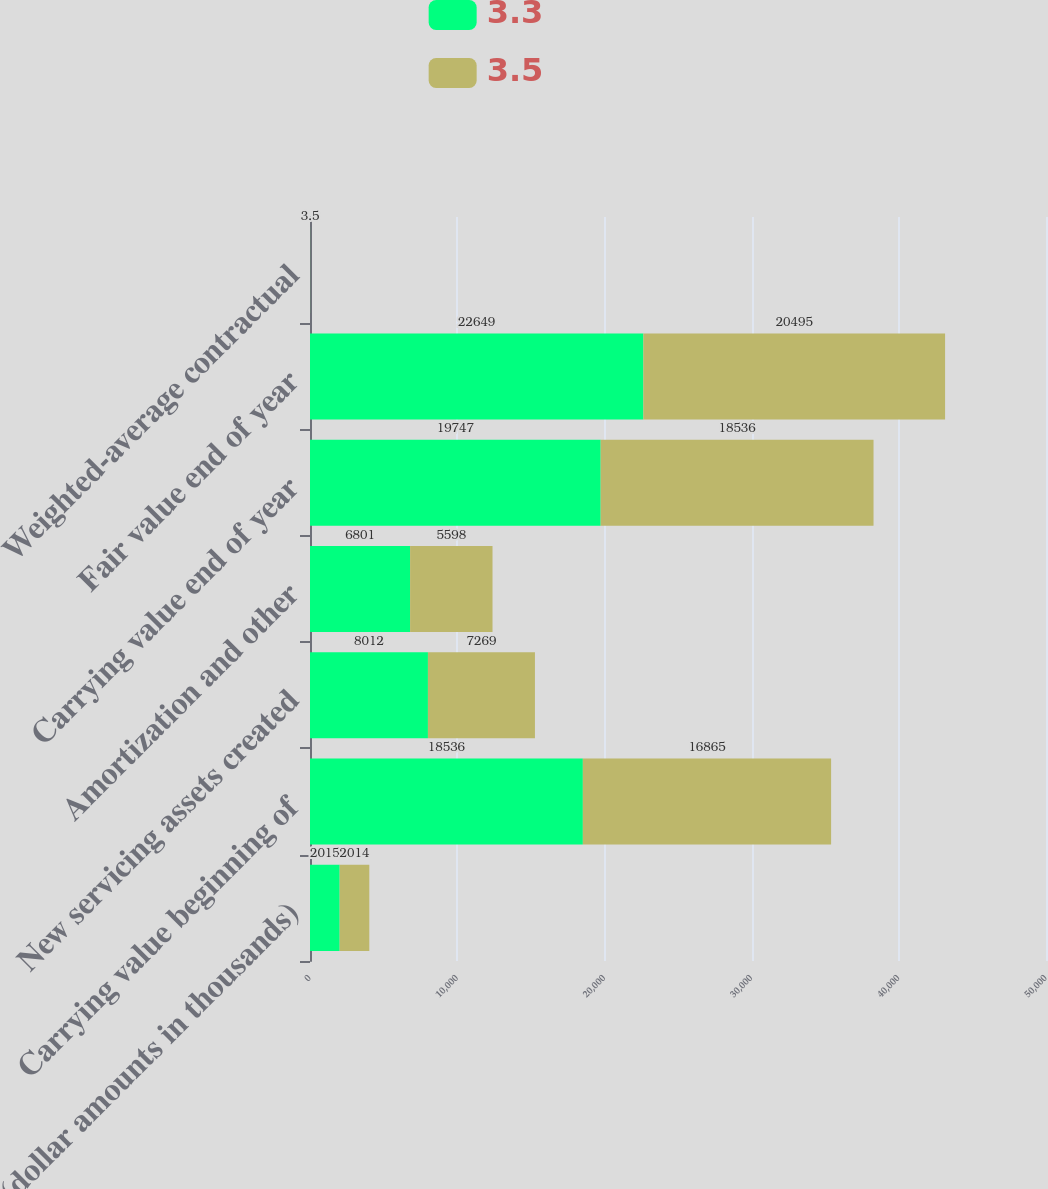Convert chart to OTSL. <chart><loc_0><loc_0><loc_500><loc_500><stacked_bar_chart><ecel><fcel>(dollar amounts in thousands)<fcel>Carrying value beginning of<fcel>New servicing assets created<fcel>Amortization and other<fcel>Carrying value end of year<fcel>Fair value end of year<fcel>Weighted-average contractual<nl><fcel>3.3<fcel>2015<fcel>18536<fcel>8012<fcel>6801<fcel>19747<fcel>22649<fcel>3.3<nl><fcel>3.5<fcel>2014<fcel>16865<fcel>7269<fcel>5598<fcel>18536<fcel>20495<fcel>3.5<nl></chart> 